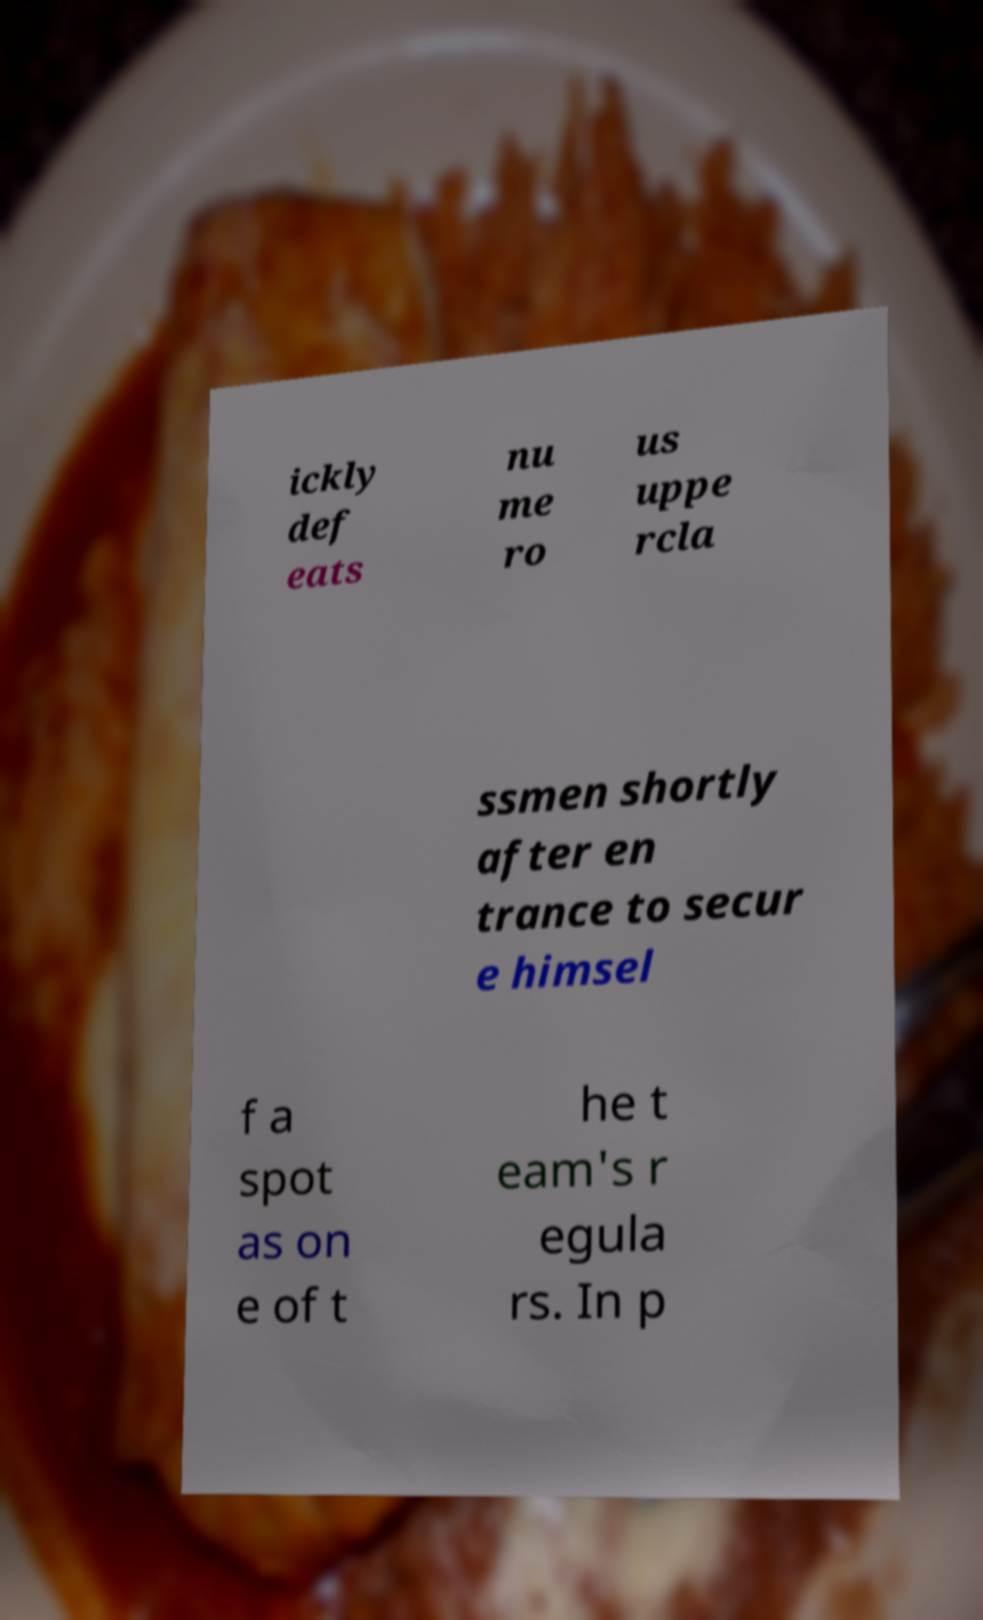Could you assist in decoding the text presented in this image and type it out clearly? ickly def eats nu me ro us uppe rcla ssmen shortly after en trance to secur e himsel f a spot as on e of t he t eam's r egula rs. In p 